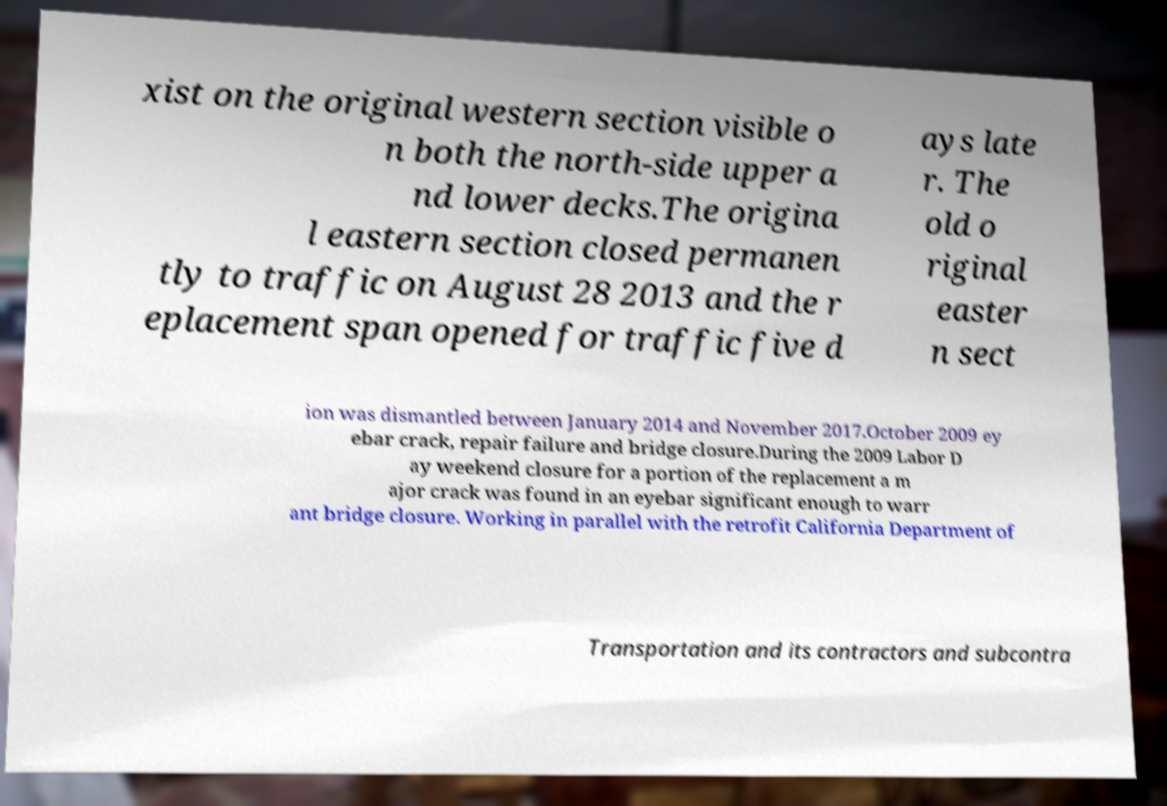What messages or text are displayed in this image? I need them in a readable, typed format. xist on the original western section visible o n both the north-side upper a nd lower decks.The origina l eastern section closed permanen tly to traffic on August 28 2013 and the r eplacement span opened for traffic five d ays late r. The old o riginal easter n sect ion was dismantled between January 2014 and November 2017.October 2009 ey ebar crack, repair failure and bridge closure.During the 2009 Labor D ay weekend closure for a portion of the replacement a m ajor crack was found in an eyebar significant enough to warr ant bridge closure. Working in parallel with the retrofit California Department of Transportation and its contractors and subcontra 